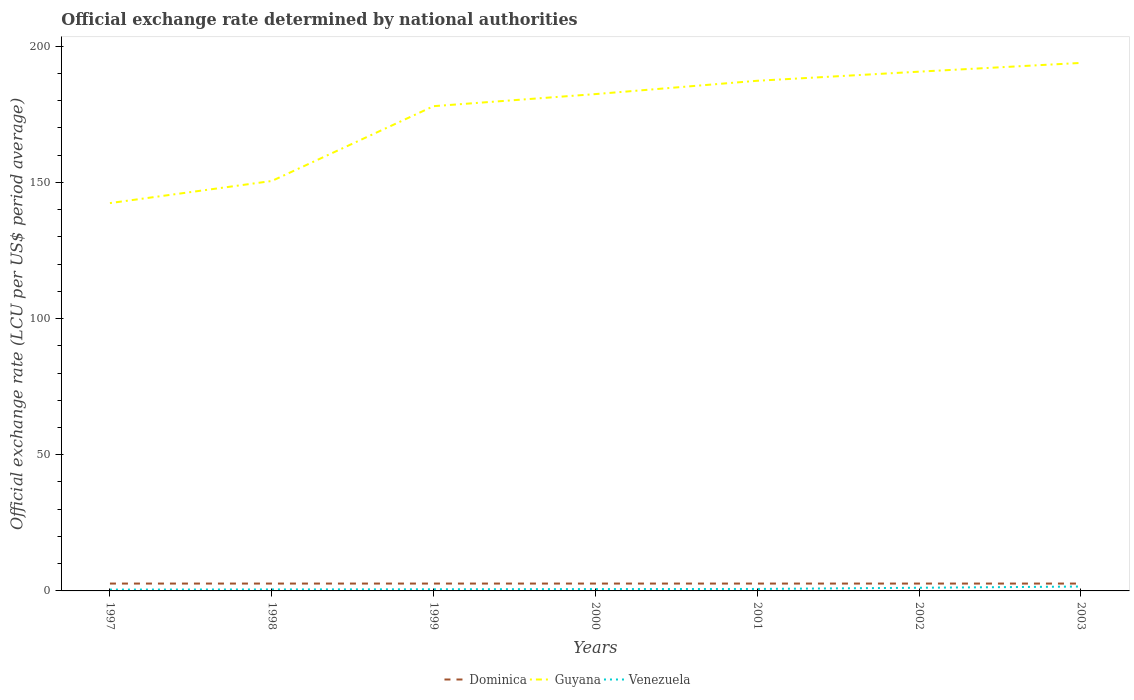Across all years, what is the maximum official exchange rate in Guyana?
Keep it short and to the point. 142.4. In which year was the official exchange rate in Venezuela maximum?
Ensure brevity in your answer.  1997. What is the total official exchange rate in Guyana in the graph?
Your answer should be very brief. -6.56. What is the difference between the highest and the second highest official exchange rate in Dominica?
Provide a succinct answer. 0. What is the difference between the highest and the lowest official exchange rate in Guyana?
Provide a short and direct response. 5. Is the official exchange rate in Dominica strictly greater than the official exchange rate in Guyana over the years?
Offer a very short reply. Yes. How many lines are there?
Offer a very short reply. 3. What is the difference between two consecutive major ticks on the Y-axis?
Make the answer very short. 50. Does the graph contain any zero values?
Provide a succinct answer. No. Where does the legend appear in the graph?
Offer a terse response. Bottom center. How are the legend labels stacked?
Ensure brevity in your answer.  Horizontal. What is the title of the graph?
Provide a succinct answer. Official exchange rate determined by national authorities. Does "Trinidad and Tobago" appear as one of the legend labels in the graph?
Your response must be concise. No. What is the label or title of the Y-axis?
Offer a very short reply. Official exchange rate (LCU per US$ period average). What is the Official exchange rate (LCU per US$ period average) of Dominica in 1997?
Make the answer very short. 2.7. What is the Official exchange rate (LCU per US$ period average) of Guyana in 1997?
Make the answer very short. 142.4. What is the Official exchange rate (LCU per US$ period average) in Venezuela in 1997?
Ensure brevity in your answer.  0.49. What is the Official exchange rate (LCU per US$ period average) of Dominica in 1998?
Offer a terse response. 2.7. What is the Official exchange rate (LCU per US$ period average) in Guyana in 1998?
Make the answer very short. 150.52. What is the Official exchange rate (LCU per US$ period average) in Venezuela in 1998?
Keep it short and to the point. 0.55. What is the Official exchange rate (LCU per US$ period average) of Guyana in 1999?
Ensure brevity in your answer.  178. What is the Official exchange rate (LCU per US$ period average) in Venezuela in 1999?
Offer a terse response. 0.61. What is the Official exchange rate (LCU per US$ period average) of Guyana in 2000?
Provide a succinct answer. 182.43. What is the Official exchange rate (LCU per US$ period average) in Venezuela in 2000?
Keep it short and to the point. 0.68. What is the Official exchange rate (LCU per US$ period average) in Guyana in 2001?
Provide a succinct answer. 187.32. What is the Official exchange rate (LCU per US$ period average) of Venezuela in 2001?
Your response must be concise. 0.72. What is the Official exchange rate (LCU per US$ period average) of Guyana in 2002?
Your answer should be very brief. 190.66. What is the Official exchange rate (LCU per US$ period average) in Venezuela in 2002?
Keep it short and to the point. 1.16. What is the Official exchange rate (LCU per US$ period average) of Guyana in 2003?
Offer a terse response. 193.88. What is the Official exchange rate (LCU per US$ period average) in Venezuela in 2003?
Keep it short and to the point. 1.61. Across all years, what is the maximum Official exchange rate (LCU per US$ period average) in Dominica?
Make the answer very short. 2.7. Across all years, what is the maximum Official exchange rate (LCU per US$ period average) in Guyana?
Your answer should be compact. 193.88. Across all years, what is the maximum Official exchange rate (LCU per US$ period average) in Venezuela?
Make the answer very short. 1.61. Across all years, what is the minimum Official exchange rate (LCU per US$ period average) in Guyana?
Your answer should be compact. 142.4. Across all years, what is the minimum Official exchange rate (LCU per US$ period average) of Venezuela?
Your answer should be very brief. 0.49. What is the total Official exchange rate (LCU per US$ period average) in Dominica in the graph?
Provide a succinct answer. 18.9. What is the total Official exchange rate (LCU per US$ period average) in Guyana in the graph?
Offer a very short reply. 1225.21. What is the total Official exchange rate (LCU per US$ period average) in Venezuela in the graph?
Your response must be concise. 5.81. What is the difference between the Official exchange rate (LCU per US$ period average) in Dominica in 1997 and that in 1998?
Provide a succinct answer. 0. What is the difference between the Official exchange rate (LCU per US$ period average) in Guyana in 1997 and that in 1998?
Make the answer very short. -8.12. What is the difference between the Official exchange rate (LCU per US$ period average) of Venezuela in 1997 and that in 1998?
Provide a short and direct response. -0.06. What is the difference between the Official exchange rate (LCU per US$ period average) in Guyana in 1997 and that in 1999?
Provide a succinct answer. -35.59. What is the difference between the Official exchange rate (LCU per US$ period average) in Venezuela in 1997 and that in 1999?
Offer a very short reply. -0.12. What is the difference between the Official exchange rate (LCU per US$ period average) in Guyana in 1997 and that in 2000?
Offer a very short reply. -40.03. What is the difference between the Official exchange rate (LCU per US$ period average) in Venezuela in 1997 and that in 2000?
Your answer should be very brief. -0.19. What is the difference between the Official exchange rate (LCU per US$ period average) in Dominica in 1997 and that in 2001?
Offer a very short reply. 0. What is the difference between the Official exchange rate (LCU per US$ period average) of Guyana in 1997 and that in 2001?
Provide a short and direct response. -44.92. What is the difference between the Official exchange rate (LCU per US$ period average) in Venezuela in 1997 and that in 2001?
Ensure brevity in your answer.  -0.23. What is the difference between the Official exchange rate (LCU per US$ period average) of Guyana in 1997 and that in 2002?
Your answer should be very brief. -48.26. What is the difference between the Official exchange rate (LCU per US$ period average) in Venezuela in 1997 and that in 2002?
Make the answer very short. -0.67. What is the difference between the Official exchange rate (LCU per US$ period average) in Guyana in 1997 and that in 2003?
Your answer should be very brief. -51.48. What is the difference between the Official exchange rate (LCU per US$ period average) in Venezuela in 1997 and that in 2003?
Ensure brevity in your answer.  -1.12. What is the difference between the Official exchange rate (LCU per US$ period average) in Guyana in 1998 and that in 1999?
Keep it short and to the point. -27.48. What is the difference between the Official exchange rate (LCU per US$ period average) in Venezuela in 1998 and that in 1999?
Provide a short and direct response. -0.06. What is the difference between the Official exchange rate (LCU per US$ period average) of Guyana in 1998 and that in 2000?
Give a very brief answer. -31.91. What is the difference between the Official exchange rate (LCU per US$ period average) in Venezuela in 1998 and that in 2000?
Provide a succinct answer. -0.13. What is the difference between the Official exchange rate (LCU per US$ period average) in Guyana in 1998 and that in 2001?
Your answer should be very brief. -36.8. What is the difference between the Official exchange rate (LCU per US$ period average) of Venezuela in 1998 and that in 2001?
Offer a terse response. -0.18. What is the difference between the Official exchange rate (LCU per US$ period average) in Dominica in 1998 and that in 2002?
Ensure brevity in your answer.  0. What is the difference between the Official exchange rate (LCU per US$ period average) of Guyana in 1998 and that in 2002?
Give a very brief answer. -40.15. What is the difference between the Official exchange rate (LCU per US$ period average) of Venezuela in 1998 and that in 2002?
Your answer should be very brief. -0.61. What is the difference between the Official exchange rate (LCU per US$ period average) in Dominica in 1998 and that in 2003?
Provide a short and direct response. 0. What is the difference between the Official exchange rate (LCU per US$ period average) in Guyana in 1998 and that in 2003?
Provide a succinct answer. -43.36. What is the difference between the Official exchange rate (LCU per US$ period average) in Venezuela in 1998 and that in 2003?
Keep it short and to the point. -1.06. What is the difference between the Official exchange rate (LCU per US$ period average) in Dominica in 1999 and that in 2000?
Offer a very short reply. 0. What is the difference between the Official exchange rate (LCU per US$ period average) in Guyana in 1999 and that in 2000?
Make the answer very short. -4.43. What is the difference between the Official exchange rate (LCU per US$ period average) of Venezuela in 1999 and that in 2000?
Keep it short and to the point. -0.07. What is the difference between the Official exchange rate (LCU per US$ period average) of Guyana in 1999 and that in 2001?
Your answer should be very brief. -9.33. What is the difference between the Official exchange rate (LCU per US$ period average) in Venezuela in 1999 and that in 2001?
Your answer should be compact. -0.12. What is the difference between the Official exchange rate (LCU per US$ period average) of Dominica in 1999 and that in 2002?
Provide a succinct answer. 0. What is the difference between the Official exchange rate (LCU per US$ period average) in Guyana in 1999 and that in 2002?
Provide a short and direct response. -12.67. What is the difference between the Official exchange rate (LCU per US$ period average) of Venezuela in 1999 and that in 2002?
Your answer should be compact. -0.56. What is the difference between the Official exchange rate (LCU per US$ period average) in Guyana in 1999 and that in 2003?
Provide a succinct answer. -15.88. What is the difference between the Official exchange rate (LCU per US$ period average) in Venezuela in 1999 and that in 2003?
Your answer should be compact. -1. What is the difference between the Official exchange rate (LCU per US$ period average) of Guyana in 2000 and that in 2001?
Provide a short and direct response. -4.89. What is the difference between the Official exchange rate (LCU per US$ period average) of Venezuela in 2000 and that in 2001?
Offer a terse response. -0.04. What is the difference between the Official exchange rate (LCU per US$ period average) in Dominica in 2000 and that in 2002?
Offer a terse response. 0. What is the difference between the Official exchange rate (LCU per US$ period average) of Guyana in 2000 and that in 2002?
Offer a very short reply. -8.23. What is the difference between the Official exchange rate (LCU per US$ period average) of Venezuela in 2000 and that in 2002?
Your response must be concise. -0.48. What is the difference between the Official exchange rate (LCU per US$ period average) in Guyana in 2000 and that in 2003?
Offer a terse response. -11.45. What is the difference between the Official exchange rate (LCU per US$ period average) of Venezuela in 2000 and that in 2003?
Ensure brevity in your answer.  -0.93. What is the difference between the Official exchange rate (LCU per US$ period average) of Guyana in 2001 and that in 2002?
Make the answer very short. -3.34. What is the difference between the Official exchange rate (LCU per US$ period average) of Venezuela in 2001 and that in 2002?
Your answer should be very brief. -0.44. What is the difference between the Official exchange rate (LCU per US$ period average) in Guyana in 2001 and that in 2003?
Provide a succinct answer. -6.56. What is the difference between the Official exchange rate (LCU per US$ period average) in Venezuela in 2001 and that in 2003?
Your answer should be very brief. -0.88. What is the difference between the Official exchange rate (LCU per US$ period average) in Guyana in 2002 and that in 2003?
Provide a succinct answer. -3.21. What is the difference between the Official exchange rate (LCU per US$ period average) of Venezuela in 2002 and that in 2003?
Give a very brief answer. -0.45. What is the difference between the Official exchange rate (LCU per US$ period average) in Dominica in 1997 and the Official exchange rate (LCU per US$ period average) in Guyana in 1998?
Offer a very short reply. -147.82. What is the difference between the Official exchange rate (LCU per US$ period average) in Dominica in 1997 and the Official exchange rate (LCU per US$ period average) in Venezuela in 1998?
Provide a short and direct response. 2.15. What is the difference between the Official exchange rate (LCU per US$ period average) of Guyana in 1997 and the Official exchange rate (LCU per US$ period average) of Venezuela in 1998?
Ensure brevity in your answer.  141.85. What is the difference between the Official exchange rate (LCU per US$ period average) in Dominica in 1997 and the Official exchange rate (LCU per US$ period average) in Guyana in 1999?
Your answer should be very brief. -175.29. What is the difference between the Official exchange rate (LCU per US$ period average) in Dominica in 1997 and the Official exchange rate (LCU per US$ period average) in Venezuela in 1999?
Your response must be concise. 2.09. What is the difference between the Official exchange rate (LCU per US$ period average) of Guyana in 1997 and the Official exchange rate (LCU per US$ period average) of Venezuela in 1999?
Provide a succinct answer. 141.8. What is the difference between the Official exchange rate (LCU per US$ period average) of Dominica in 1997 and the Official exchange rate (LCU per US$ period average) of Guyana in 2000?
Your answer should be compact. -179.73. What is the difference between the Official exchange rate (LCU per US$ period average) of Dominica in 1997 and the Official exchange rate (LCU per US$ period average) of Venezuela in 2000?
Provide a succinct answer. 2.02. What is the difference between the Official exchange rate (LCU per US$ period average) in Guyana in 1997 and the Official exchange rate (LCU per US$ period average) in Venezuela in 2000?
Give a very brief answer. 141.72. What is the difference between the Official exchange rate (LCU per US$ period average) of Dominica in 1997 and the Official exchange rate (LCU per US$ period average) of Guyana in 2001?
Your response must be concise. -184.62. What is the difference between the Official exchange rate (LCU per US$ period average) of Dominica in 1997 and the Official exchange rate (LCU per US$ period average) of Venezuela in 2001?
Make the answer very short. 1.98. What is the difference between the Official exchange rate (LCU per US$ period average) of Guyana in 1997 and the Official exchange rate (LCU per US$ period average) of Venezuela in 2001?
Ensure brevity in your answer.  141.68. What is the difference between the Official exchange rate (LCU per US$ period average) in Dominica in 1997 and the Official exchange rate (LCU per US$ period average) in Guyana in 2002?
Ensure brevity in your answer.  -187.97. What is the difference between the Official exchange rate (LCU per US$ period average) in Dominica in 1997 and the Official exchange rate (LCU per US$ period average) in Venezuela in 2002?
Your answer should be compact. 1.54. What is the difference between the Official exchange rate (LCU per US$ period average) of Guyana in 1997 and the Official exchange rate (LCU per US$ period average) of Venezuela in 2002?
Your response must be concise. 141.24. What is the difference between the Official exchange rate (LCU per US$ period average) of Dominica in 1997 and the Official exchange rate (LCU per US$ period average) of Guyana in 2003?
Your answer should be compact. -191.18. What is the difference between the Official exchange rate (LCU per US$ period average) of Dominica in 1997 and the Official exchange rate (LCU per US$ period average) of Venezuela in 2003?
Your answer should be compact. 1.09. What is the difference between the Official exchange rate (LCU per US$ period average) in Guyana in 1997 and the Official exchange rate (LCU per US$ period average) in Venezuela in 2003?
Offer a very short reply. 140.79. What is the difference between the Official exchange rate (LCU per US$ period average) of Dominica in 1998 and the Official exchange rate (LCU per US$ period average) of Guyana in 1999?
Make the answer very short. -175.29. What is the difference between the Official exchange rate (LCU per US$ period average) in Dominica in 1998 and the Official exchange rate (LCU per US$ period average) in Venezuela in 1999?
Make the answer very short. 2.09. What is the difference between the Official exchange rate (LCU per US$ period average) of Guyana in 1998 and the Official exchange rate (LCU per US$ period average) of Venezuela in 1999?
Your response must be concise. 149.91. What is the difference between the Official exchange rate (LCU per US$ period average) of Dominica in 1998 and the Official exchange rate (LCU per US$ period average) of Guyana in 2000?
Provide a succinct answer. -179.73. What is the difference between the Official exchange rate (LCU per US$ period average) of Dominica in 1998 and the Official exchange rate (LCU per US$ period average) of Venezuela in 2000?
Your answer should be very brief. 2.02. What is the difference between the Official exchange rate (LCU per US$ period average) of Guyana in 1998 and the Official exchange rate (LCU per US$ period average) of Venezuela in 2000?
Offer a very short reply. 149.84. What is the difference between the Official exchange rate (LCU per US$ period average) of Dominica in 1998 and the Official exchange rate (LCU per US$ period average) of Guyana in 2001?
Provide a succinct answer. -184.62. What is the difference between the Official exchange rate (LCU per US$ period average) in Dominica in 1998 and the Official exchange rate (LCU per US$ period average) in Venezuela in 2001?
Offer a terse response. 1.98. What is the difference between the Official exchange rate (LCU per US$ period average) of Guyana in 1998 and the Official exchange rate (LCU per US$ period average) of Venezuela in 2001?
Ensure brevity in your answer.  149.8. What is the difference between the Official exchange rate (LCU per US$ period average) in Dominica in 1998 and the Official exchange rate (LCU per US$ period average) in Guyana in 2002?
Give a very brief answer. -187.97. What is the difference between the Official exchange rate (LCU per US$ period average) in Dominica in 1998 and the Official exchange rate (LCU per US$ period average) in Venezuela in 2002?
Give a very brief answer. 1.54. What is the difference between the Official exchange rate (LCU per US$ period average) of Guyana in 1998 and the Official exchange rate (LCU per US$ period average) of Venezuela in 2002?
Give a very brief answer. 149.36. What is the difference between the Official exchange rate (LCU per US$ period average) of Dominica in 1998 and the Official exchange rate (LCU per US$ period average) of Guyana in 2003?
Your response must be concise. -191.18. What is the difference between the Official exchange rate (LCU per US$ period average) of Dominica in 1998 and the Official exchange rate (LCU per US$ period average) of Venezuela in 2003?
Provide a short and direct response. 1.09. What is the difference between the Official exchange rate (LCU per US$ period average) in Guyana in 1998 and the Official exchange rate (LCU per US$ period average) in Venezuela in 2003?
Provide a succinct answer. 148.91. What is the difference between the Official exchange rate (LCU per US$ period average) in Dominica in 1999 and the Official exchange rate (LCU per US$ period average) in Guyana in 2000?
Your response must be concise. -179.73. What is the difference between the Official exchange rate (LCU per US$ period average) of Dominica in 1999 and the Official exchange rate (LCU per US$ period average) of Venezuela in 2000?
Provide a succinct answer. 2.02. What is the difference between the Official exchange rate (LCU per US$ period average) in Guyana in 1999 and the Official exchange rate (LCU per US$ period average) in Venezuela in 2000?
Keep it short and to the point. 177.31. What is the difference between the Official exchange rate (LCU per US$ period average) in Dominica in 1999 and the Official exchange rate (LCU per US$ period average) in Guyana in 2001?
Provide a succinct answer. -184.62. What is the difference between the Official exchange rate (LCU per US$ period average) of Dominica in 1999 and the Official exchange rate (LCU per US$ period average) of Venezuela in 2001?
Give a very brief answer. 1.98. What is the difference between the Official exchange rate (LCU per US$ period average) of Guyana in 1999 and the Official exchange rate (LCU per US$ period average) of Venezuela in 2001?
Make the answer very short. 177.27. What is the difference between the Official exchange rate (LCU per US$ period average) in Dominica in 1999 and the Official exchange rate (LCU per US$ period average) in Guyana in 2002?
Make the answer very short. -187.97. What is the difference between the Official exchange rate (LCU per US$ period average) in Dominica in 1999 and the Official exchange rate (LCU per US$ period average) in Venezuela in 2002?
Your response must be concise. 1.54. What is the difference between the Official exchange rate (LCU per US$ period average) in Guyana in 1999 and the Official exchange rate (LCU per US$ period average) in Venezuela in 2002?
Your answer should be compact. 176.83. What is the difference between the Official exchange rate (LCU per US$ period average) of Dominica in 1999 and the Official exchange rate (LCU per US$ period average) of Guyana in 2003?
Give a very brief answer. -191.18. What is the difference between the Official exchange rate (LCU per US$ period average) in Dominica in 1999 and the Official exchange rate (LCU per US$ period average) in Venezuela in 2003?
Give a very brief answer. 1.09. What is the difference between the Official exchange rate (LCU per US$ period average) in Guyana in 1999 and the Official exchange rate (LCU per US$ period average) in Venezuela in 2003?
Provide a succinct answer. 176.39. What is the difference between the Official exchange rate (LCU per US$ period average) of Dominica in 2000 and the Official exchange rate (LCU per US$ period average) of Guyana in 2001?
Provide a short and direct response. -184.62. What is the difference between the Official exchange rate (LCU per US$ period average) in Dominica in 2000 and the Official exchange rate (LCU per US$ period average) in Venezuela in 2001?
Keep it short and to the point. 1.98. What is the difference between the Official exchange rate (LCU per US$ period average) in Guyana in 2000 and the Official exchange rate (LCU per US$ period average) in Venezuela in 2001?
Give a very brief answer. 181.71. What is the difference between the Official exchange rate (LCU per US$ period average) in Dominica in 2000 and the Official exchange rate (LCU per US$ period average) in Guyana in 2002?
Keep it short and to the point. -187.97. What is the difference between the Official exchange rate (LCU per US$ period average) of Dominica in 2000 and the Official exchange rate (LCU per US$ period average) of Venezuela in 2002?
Provide a succinct answer. 1.54. What is the difference between the Official exchange rate (LCU per US$ period average) in Guyana in 2000 and the Official exchange rate (LCU per US$ period average) in Venezuela in 2002?
Keep it short and to the point. 181.27. What is the difference between the Official exchange rate (LCU per US$ period average) in Dominica in 2000 and the Official exchange rate (LCU per US$ period average) in Guyana in 2003?
Your answer should be compact. -191.18. What is the difference between the Official exchange rate (LCU per US$ period average) of Dominica in 2000 and the Official exchange rate (LCU per US$ period average) of Venezuela in 2003?
Offer a terse response. 1.09. What is the difference between the Official exchange rate (LCU per US$ period average) of Guyana in 2000 and the Official exchange rate (LCU per US$ period average) of Venezuela in 2003?
Your answer should be very brief. 180.82. What is the difference between the Official exchange rate (LCU per US$ period average) of Dominica in 2001 and the Official exchange rate (LCU per US$ period average) of Guyana in 2002?
Provide a succinct answer. -187.97. What is the difference between the Official exchange rate (LCU per US$ period average) in Dominica in 2001 and the Official exchange rate (LCU per US$ period average) in Venezuela in 2002?
Your answer should be very brief. 1.54. What is the difference between the Official exchange rate (LCU per US$ period average) in Guyana in 2001 and the Official exchange rate (LCU per US$ period average) in Venezuela in 2002?
Provide a short and direct response. 186.16. What is the difference between the Official exchange rate (LCU per US$ period average) in Dominica in 2001 and the Official exchange rate (LCU per US$ period average) in Guyana in 2003?
Your response must be concise. -191.18. What is the difference between the Official exchange rate (LCU per US$ period average) of Dominica in 2001 and the Official exchange rate (LCU per US$ period average) of Venezuela in 2003?
Offer a terse response. 1.09. What is the difference between the Official exchange rate (LCU per US$ period average) of Guyana in 2001 and the Official exchange rate (LCU per US$ period average) of Venezuela in 2003?
Keep it short and to the point. 185.71. What is the difference between the Official exchange rate (LCU per US$ period average) in Dominica in 2002 and the Official exchange rate (LCU per US$ period average) in Guyana in 2003?
Make the answer very short. -191.18. What is the difference between the Official exchange rate (LCU per US$ period average) in Dominica in 2002 and the Official exchange rate (LCU per US$ period average) in Venezuela in 2003?
Make the answer very short. 1.09. What is the difference between the Official exchange rate (LCU per US$ period average) of Guyana in 2002 and the Official exchange rate (LCU per US$ period average) of Venezuela in 2003?
Offer a terse response. 189.06. What is the average Official exchange rate (LCU per US$ period average) of Guyana per year?
Your answer should be very brief. 175.03. What is the average Official exchange rate (LCU per US$ period average) of Venezuela per year?
Your answer should be compact. 0.83. In the year 1997, what is the difference between the Official exchange rate (LCU per US$ period average) in Dominica and Official exchange rate (LCU per US$ period average) in Guyana?
Make the answer very short. -139.7. In the year 1997, what is the difference between the Official exchange rate (LCU per US$ period average) in Dominica and Official exchange rate (LCU per US$ period average) in Venezuela?
Ensure brevity in your answer.  2.21. In the year 1997, what is the difference between the Official exchange rate (LCU per US$ period average) of Guyana and Official exchange rate (LCU per US$ period average) of Venezuela?
Your answer should be compact. 141.91. In the year 1998, what is the difference between the Official exchange rate (LCU per US$ period average) in Dominica and Official exchange rate (LCU per US$ period average) in Guyana?
Offer a very short reply. -147.82. In the year 1998, what is the difference between the Official exchange rate (LCU per US$ period average) in Dominica and Official exchange rate (LCU per US$ period average) in Venezuela?
Provide a short and direct response. 2.15. In the year 1998, what is the difference between the Official exchange rate (LCU per US$ period average) in Guyana and Official exchange rate (LCU per US$ period average) in Venezuela?
Offer a terse response. 149.97. In the year 1999, what is the difference between the Official exchange rate (LCU per US$ period average) of Dominica and Official exchange rate (LCU per US$ period average) of Guyana?
Offer a very short reply. -175.29. In the year 1999, what is the difference between the Official exchange rate (LCU per US$ period average) in Dominica and Official exchange rate (LCU per US$ period average) in Venezuela?
Provide a succinct answer. 2.09. In the year 1999, what is the difference between the Official exchange rate (LCU per US$ period average) of Guyana and Official exchange rate (LCU per US$ period average) of Venezuela?
Keep it short and to the point. 177.39. In the year 2000, what is the difference between the Official exchange rate (LCU per US$ period average) of Dominica and Official exchange rate (LCU per US$ period average) of Guyana?
Your response must be concise. -179.73. In the year 2000, what is the difference between the Official exchange rate (LCU per US$ period average) of Dominica and Official exchange rate (LCU per US$ period average) of Venezuela?
Make the answer very short. 2.02. In the year 2000, what is the difference between the Official exchange rate (LCU per US$ period average) in Guyana and Official exchange rate (LCU per US$ period average) in Venezuela?
Keep it short and to the point. 181.75. In the year 2001, what is the difference between the Official exchange rate (LCU per US$ period average) of Dominica and Official exchange rate (LCU per US$ period average) of Guyana?
Offer a very short reply. -184.62. In the year 2001, what is the difference between the Official exchange rate (LCU per US$ period average) in Dominica and Official exchange rate (LCU per US$ period average) in Venezuela?
Offer a terse response. 1.98. In the year 2001, what is the difference between the Official exchange rate (LCU per US$ period average) in Guyana and Official exchange rate (LCU per US$ period average) in Venezuela?
Make the answer very short. 186.6. In the year 2002, what is the difference between the Official exchange rate (LCU per US$ period average) of Dominica and Official exchange rate (LCU per US$ period average) of Guyana?
Provide a short and direct response. -187.97. In the year 2002, what is the difference between the Official exchange rate (LCU per US$ period average) of Dominica and Official exchange rate (LCU per US$ period average) of Venezuela?
Offer a very short reply. 1.54. In the year 2002, what is the difference between the Official exchange rate (LCU per US$ period average) of Guyana and Official exchange rate (LCU per US$ period average) of Venezuela?
Your answer should be compact. 189.5. In the year 2003, what is the difference between the Official exchange rate (LCU per US$ period average) of Dominica and Official exchange rate (LCU per US$ period average) of Guyana?
Ensure brevity in your answer.  -191.18. In the year 2003, what is the difference between the Official exchange rate (LCU per US$ period average) in Dominica and Official exchange rate (LCU per US$ period average) in Venezuela?
Offer a very short reply. 1.09. In the year 2003, what is the difference between the Official exchange rate (LCU per US$ period average) of Guyana and Official exchange rate (LCU per US$ period average) of Venezuela?
Your answer should be very brief. 192.27. What is the ratio of the Official exchange rate (LCU per US$ period average) in Dominica in 1997 to that in 1998?
Keep it short and to the point. 1. What is the ratio of the Official exchange rate (LCU per US$ period average) of Guyana in 1997 to that in 1998?
Your response must be concise. 0.95. What is the ratio of the Official exchange rate (LCU per US$ period average) in Venezuela in 1997 to that in 1998?
Your answer should be very brief. 0.89. What is the ratio of the Official exchange rate (LCU per US$ period average) of Guyana in 1997 to that in 1999?
Provide a short and direct response. 0.8. What is the ratio of the Official exchange rate (LCU per US$ period average) in Venezuela in 1997 to that in 1999?
Provide a succinct answer. 0.81. What is the ratio of the Official exchange rate (LCU per US$ period average) in Dominica in 1997 to that in 2000?
Provide a succinct answer. 1. What is the ratio of the Official exchange rate (LCU per US$ period average) in Guyana in 1997 to that in 2000?
Provide a succinct answer. 0.78. What is the ratio of the Official exchange rate (LCU per US$ period average) in Venezuela in 1997 to that in 2000?
Your answer should be very brief. 0.72. What is the ratio of the Official exchange rate (LCU per US$ period average) in Dominica in 1997 to that in 2001?
Provide a short and direct response. 1. What is the ratio of the Official exchange rate (LCU per US$ period average) of Guyana in 1997 to that in 2001?
Your answer should be compact. 0.76. What is the ratio of the Official exchange rate (LCU per US$ period average) of Venezuela in 1997 to that in 2001?
Offer a very short reply. 0.68. What is the ratio of the Official exchange rate (LCU per US$ period average) in Guyana in 1997 to that in 2002?
Your answer should be very brief. 0.75. What is the ratio of the Official exchange rate (LCU per US$ period average) of Venezuela in 1997 to that in 2002?
Provide a succinct answer. 0.42. What is the ratio of the Official exchange rate (LCU per US$ period average) in Guyana in 1997 to that in 2003?
Your answer should be compact. 0.73. What is the ratio of the Official exchange rate (LCU per US$ period average) in Venezuela in 1997 to that in 2003?
Offer a very short reply. 0.3. What is the ratio of the Official exchange rate (LCU per US$ period average) in Dominica in 1998 to that in 1999?
Provide a short and direct response. 1. What is the ratio of the Official exchange rate (LCU per US$ period average) of Guyana in 1998 to that in 1999?
Ensure brevity in your answer.  0.85. What is the ratio of the Official exchange rate (LCU per US$ period average) of Venezuela in 1998 to that in 1999?
Give a very brief answer. 0.9. What is the ratio of the Official exchange rate (LCU per US$ period average) in Dominica in 1998 to that in 2000?
Keep it short and to the point. 1. What is the ratio of the Official exchange rate (LCU per US$ period average) in Guyana in 1998 to that in 2000?
Provide a short and direct response. 0.83. What is the ratio of the Official exchange rate (LCU per US$ period average) in Venezuela in 1998 to that in 2000?
Provide a succinct answer. 0.81. What is the ratio of the Official exchange rate (LCU per US$ period average) of Guyana in 1998 to that in 2001?
Your answer should be compact. 0.8. What is the ratio of the Official exchange rate (LCU per US$ period average) of Venezuela in 1998 to that in 2001?
Offer a very short reply. 0.76. What is the ratio of the Official exchange rate (LCU per US$ period average) of Guyana in 1998 to that in 2002?
Give a very brief answer. 0.79. What is the ratio of the Official exchange rate (LCU per US$ period average) of Venezuela in 1998 to that in 2002?
Offer a terse response. 0.47. What is the ratio of the Official exchange rate (LCU per US$ period average) of Guyana in 1998 to that in 2003?
Provide a succinct answer. 0.78. What is the ratio of the Official exchange rate (LCU per US$ period average) of Venezuela in 1998 to that in 2003?
Make the answer very short. 0.34. What is the ratio of the Official exchange rate (LCU per US$ period average) in Guyana in 1999 to that in 2000?
Make the answer very short. 0.98. What is the ratio of the Official exchange rate (LCU per US$ period average) of Venezuela in 1999 to that in 2000?
Keep it short and to the point. 0.89. What is the ratio of the Official exchange rate (LCU per US$ period average) of Dominica in 1999 to that in 2001?
Your answer should be compact. 1. What is the ratio of the Official exchange rate (LCU per US$ period average) of Guyana in 1999 to that in 2001?
Provide a short and direct response. 0.95. What is the ratio of the Official exchange rate (LCU per US$ period average) in Venezuela in 1999 to that in 2001?
Your response must be concise. 0.84. What is the ratio of the Official exchange rate (LCU per US$ period average) of Guyana in 1999 to that in 2002?
Ensure brevity in your answer.  0.93. What is the ratio of the Official exchange rate (LCU per US$ period average) in Venezuela in 1999 to that in 2002?
Provide a succinct answer. 0.52. What is the ratio of the Official exchange rate (LCU per US$ period average) in Guyana in 1999 to that in 2003?
Give a very brief answer. 0.92. What is the ratio of the Official exchange rate (LCU per US$ period average) in Venezuela in 1999 to that in 2003?
Give a very brief answer. 0.38. What is the ratio of the Official exchange rate (LCU per US$ period average) of Guyana in 2000 to that in 2001?
Offer a terse response. 0.97. What is the ratio of the Official exchange rate (LCU per US$ period average) of Venezuela in 2000 to that in 2001?
Make the answer very short. 0.94. What is the ratio of the Official exchange rate (LCU per US$ period average) in Dominica in 2000 to that in 2002?
Provide a succinct answer. 1. What is the ratio of the Official exchange rate (LCU per US$ period average) in Guyana in 2000 to that in 2002?
Provide a short and direct response. 0.96. What is the ratio of the Official exchange rate (LCU per US$ period average) in Venezuela in 2000 to that in 2002?
Your response must be concise. 0.59. What is the ratio of the Official exchange rate (LCU per US$ period average) in Guyana in 2000 to that in 2003?
Your response must be concise. 0.94. What is the ratio of the Official exchange rate (LCU per US$ period average) of Venezuela in 2000 to that in 2003?
Provide a succinct answer. 0.42. What is the ratio of the Official exchange rate (LCU per US$ period average) of Guyana in 2001 to that in 2002?
Offer a very short reply. 0.98. What is the ratio of the Official exchange rate (LCU per US$ period average) of Venezuela in 2001 to that in 2002?
Keep it short and to the point. 0.62. What is the ratio of the Official exchange rate (LCU per US$ period average) in Dominica in 2001 to that in 2003?
Make the answer very short. 1. What is the ratio of the Official exchange rate (LCU per US$ period average) of Guyana in 2001 to that in 2003?
Your answer should be very brief. 0.97. What is the ratio of the Official exchange rate (LCU per US$ period average) in Venezuela in 2001 to that in 2003?
Ensure brevity in your answer.  0.45. What is the ratio of the Official exchange rate (LCU per US$ period average) in Dominica in 2002 to that in 2003?
Offer a terse response. 1. What is the ratio of the Official exchange rate (LCU per US$ period average) in Guyana in 2002 to that in 2003?
Make the answer very short. 0.98. What is the ratio of the Official exchange rate (LCU per US$ period average) in Venezuela in 2002 to that in 2003?
Ensure brevity in your answer.  0.72. What is the difference between the highest and the second highest Official exchange rate (LCU per US$ period average) of Guyana?
Make the answer very short. 3.21. What is the difference between the highest and the second highest Official exchange rate (LCU per US$ period average) in Venezuela?
Provide a short and direct response. 0.45. What is the difference between the highest and the lowest Official exchange rate (LCU per US$ period average) in Guyana?
Your answer should be very brief. 51.48. What is the difference between the highest and the lowest Official exchange rate (LCU per US$ period average) of Venezuela?
Make the answer very short. 1.12. 